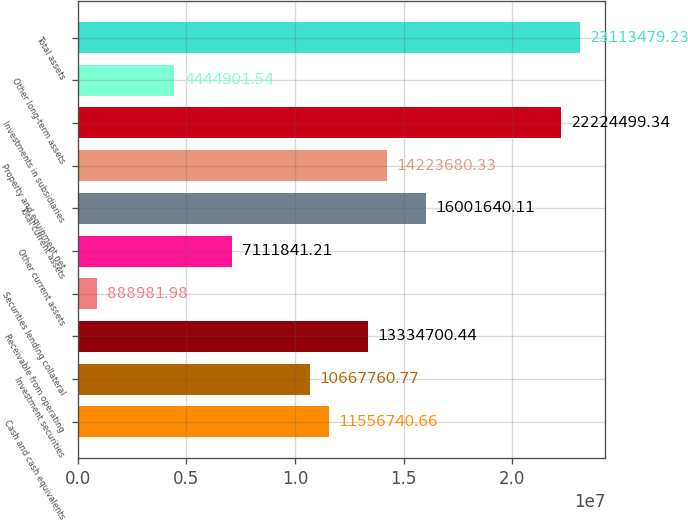Convert chart. <chart><loc_0><loc_0><loc_500><loc_500><bar_chart><fcel>Cash and cash equivalents<fcel>Investment securities<fcel>Receivable from operating<fcel>Securities lending collateral<fcel>Other current assets<fcel>Total current assets<fcel>Property and equipment net<fcel>Investments in subsidiaries<fcel>Other long-term assets<fcel>Total assets<nl><fcel>1.15567e+07<fcel>1.06678e+07<fcel>1.33347e+07<fcel>888982<fcel>7.11184e+06<fcel>1.60016e+07<fcel>1.42237e+07<fcel>2.22245e+07<fcel>4.4449e+06<fcel>2.31135e+07<nl></chart> 